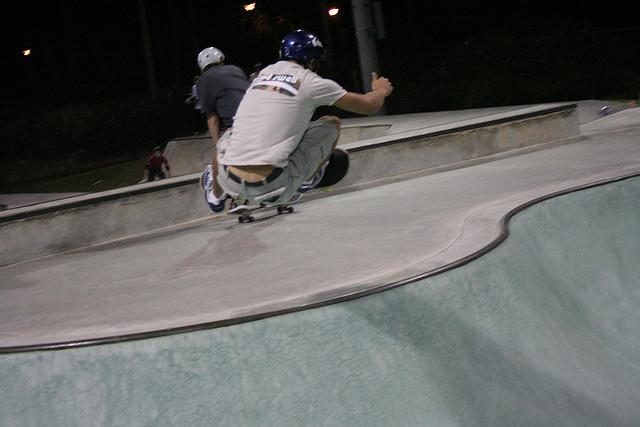Are these skateboarders wearing helmets?
Short answer required. Yes. Is this man wearing any safety gear?
Write a very short answer. Yes. Are these people at a skate park?
Keep it brief. Yes. Is this place specifically for skateboarding?
Give a very brief answer. Yes. 